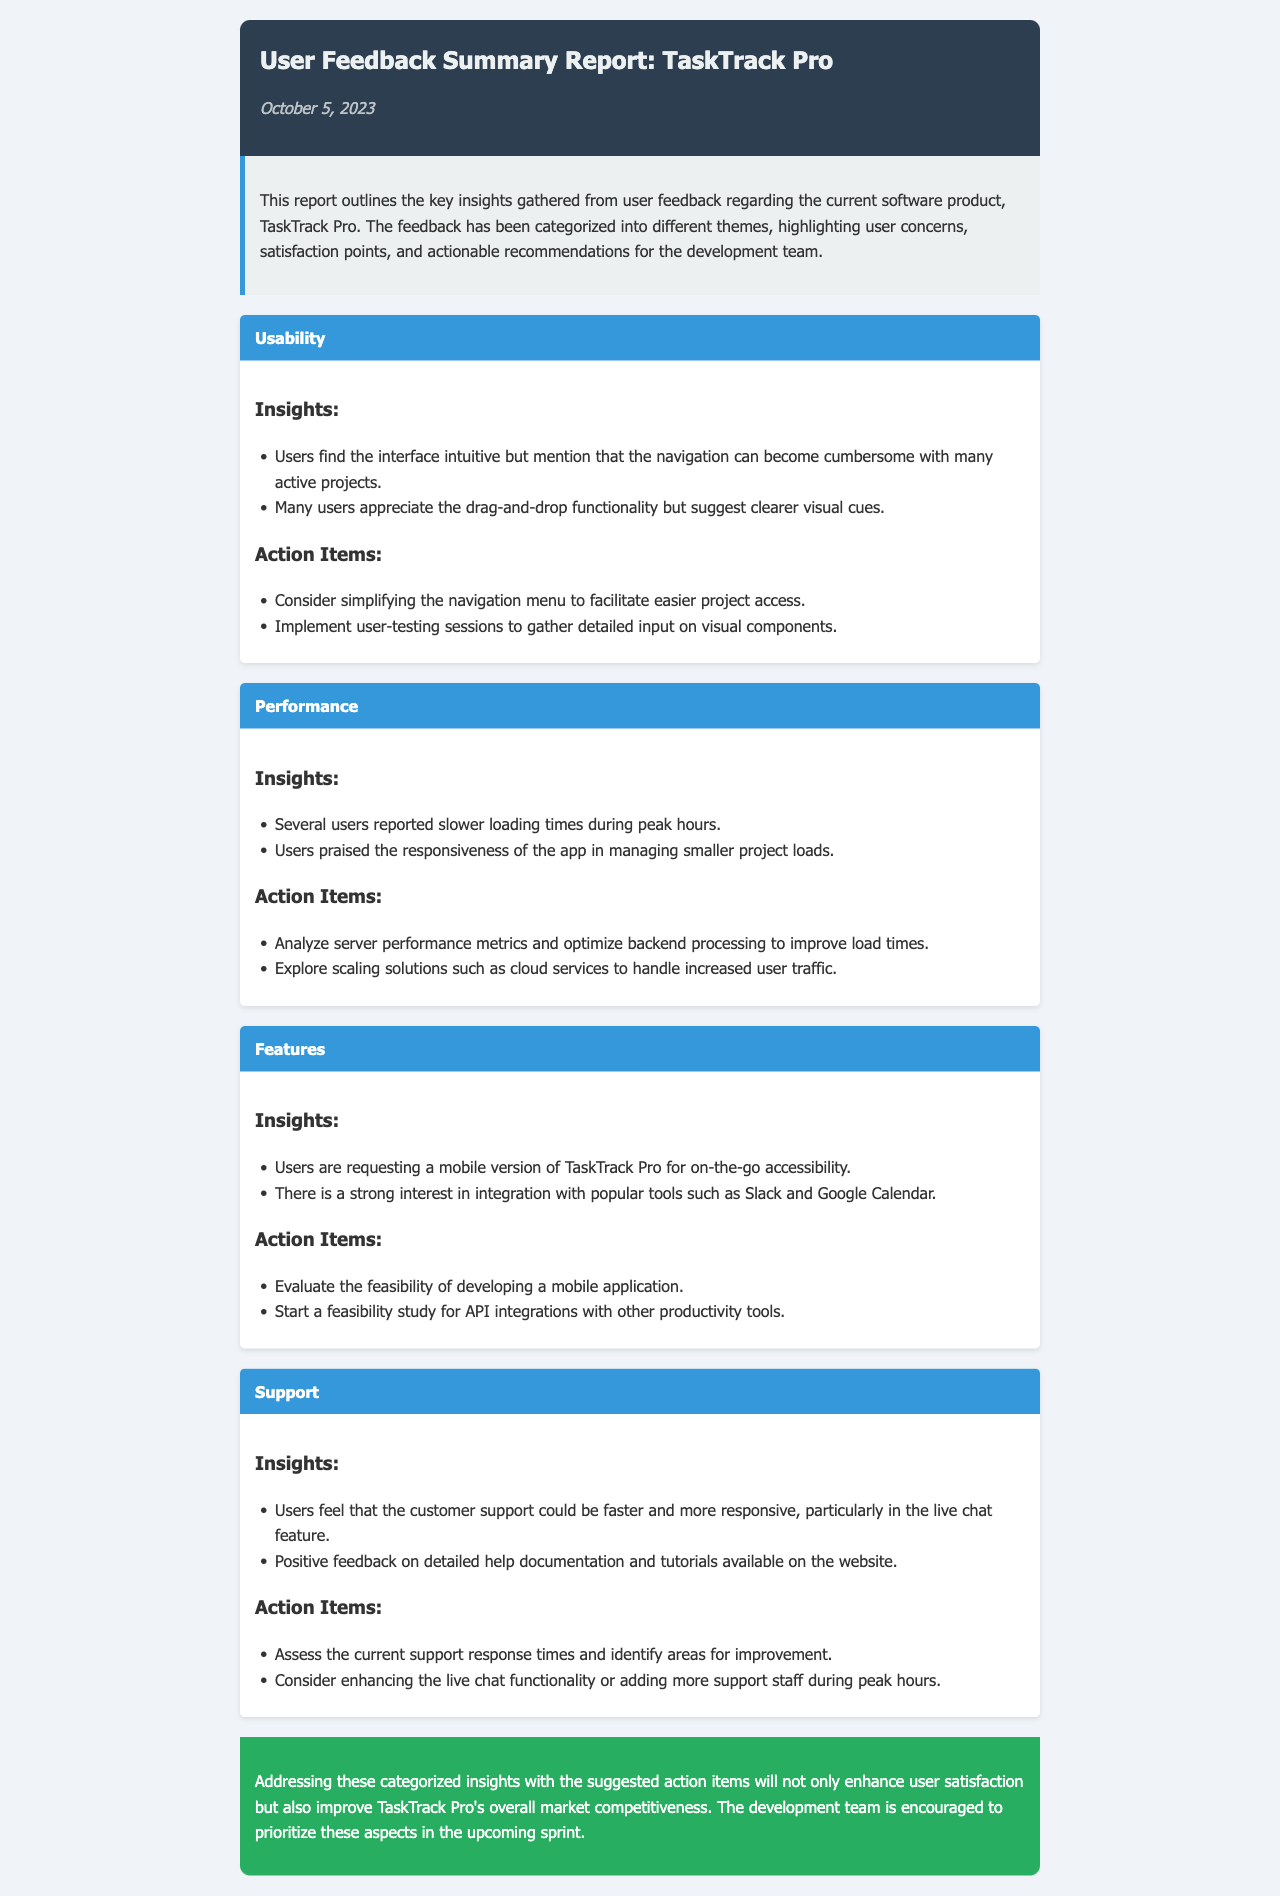What is the title of the report? The title of the report is found in the header section, which describes the content of the document.
Answer: User Feedback Summary Report: TaskTrack Pro What date was the report published? The date is mentioned right below the title in a stylized format.
Answer: October 5, 2023 What is one insight from the Usability category? This insight is listed as a key user observation under the Usability category in the document.
Answer: Users find the interface intuitive but mention that the navigation can become cumbersome with many active projects What action item is suggested for Performance? This action item addresses performance issues based on user feedback and is meant for the development team's focus.
Answer: Analyze server performance metrics and optimize backend processing to improve load times How many user feedback categories are mentioned in the report? The count of categories can be determined by examining the category sections in the document.
Answer: Four What is one request from users regarding Features? This request is outlined under the Features category, reflecting user needs for enhancements.
Answer: Users are requesting a mobile version of TaskTrack Pro for on-the-go accessibility What is the main conclusion of the report? The conclusion summarizes the report's findings and presents an overarching suggestion to the development team.
Answer: Addressing these categorized insights with the suggested action items will not only enhance user satisfaction but also improve TaskTrack Pro's overall market competitiveness Which feature of the support was positively noted by users? This information can be found within the Support category, highlighting user feedback on customer assistance.
Answer: Positive feedback on detailed help documentation and tutorials available on the website 